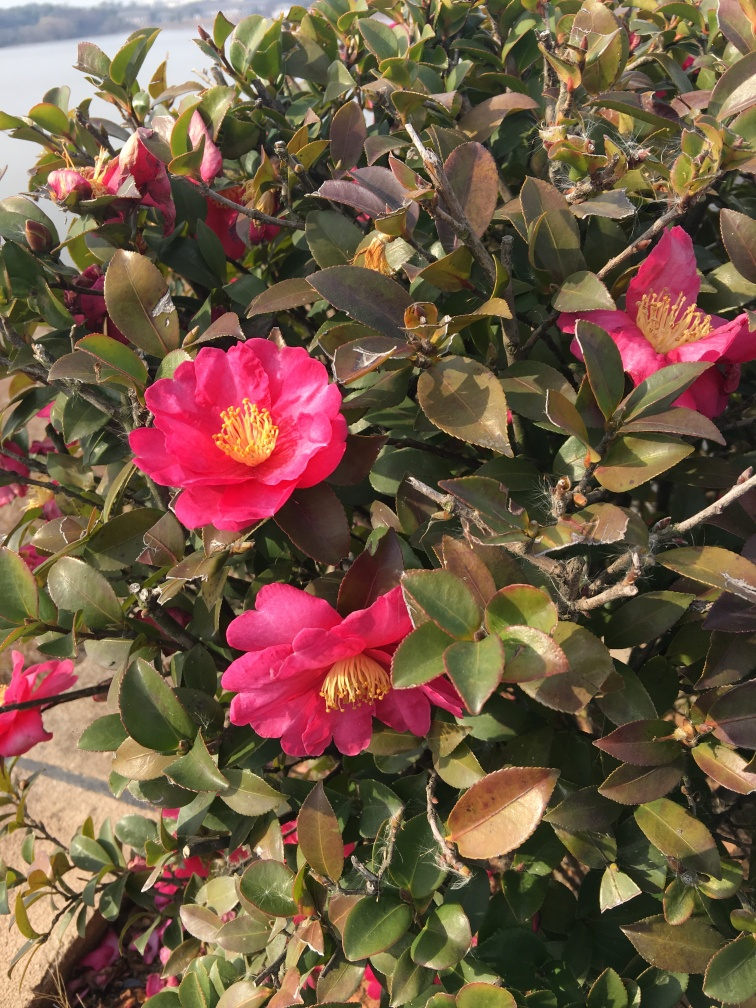What is the main subject of the image? The image prominently features camellia flowers in full bloom, showcasing their vibrant pink petals with a burst of yellow stamens at the center, which contrasts beautifully against the waxy greenery of the foliage. 